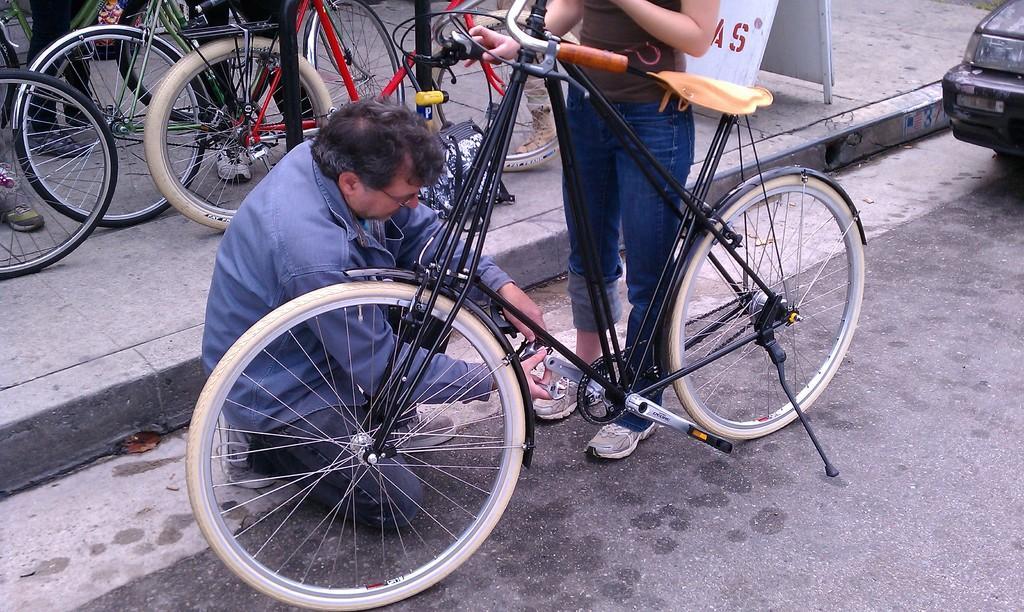In one or two sentences, can you explain what this image depicts? In this image I can see the road, a car which is black in color and a bicycle which is black in color on the road. I can see a person is sitting and a person is standing beside the bicycle. I can see the sidewalk and on the side walk I can see few bicycles and a white colored board. 